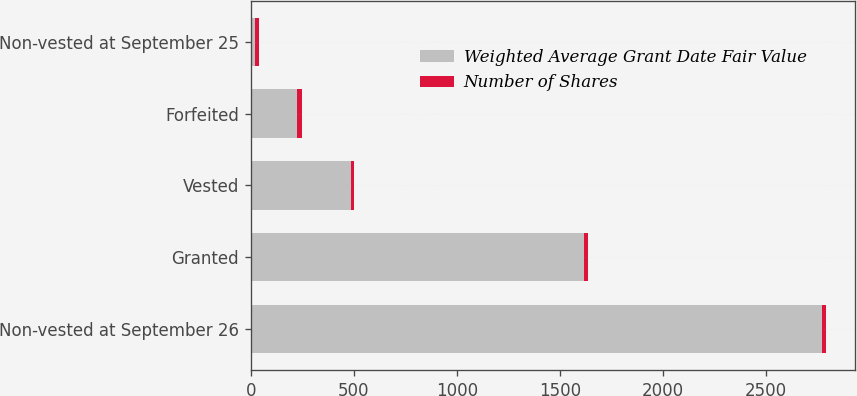Convert chart. <chart><loc_0><loc_0><loc_500><loc_500><stacked_bar_chart><ecel><fcel>Non-vested at September 26<fcel>Granted<fcel>Vested<fcel>Forfeited<fcel>Non-vested at September 25<nl><fcel>Weighted Average Grant Date Fair Value<fcel>2770<fcel>1619<fcel>487<fcel>226<fcel>21.96<nl><fcel>Number of Shares<fcel>21.96<fcel>15.27<fcel>15.47<fcel>21.49<fcel>19.9<nl></chart> 